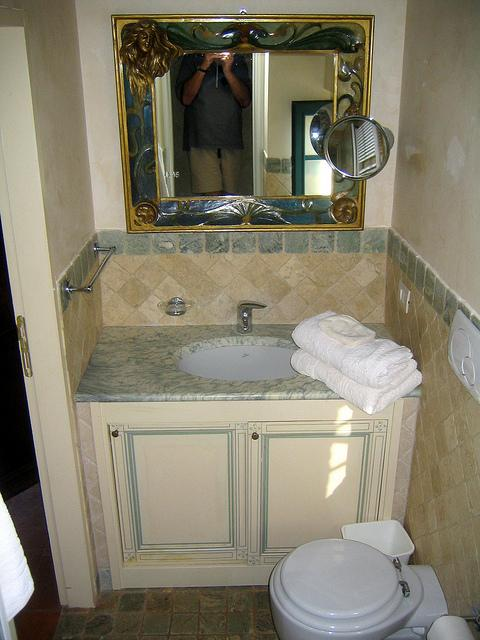What type of mirror is the small circular one referred to as?

Choices:
A) circular
B) make-up
C) extra
D) round make-up 